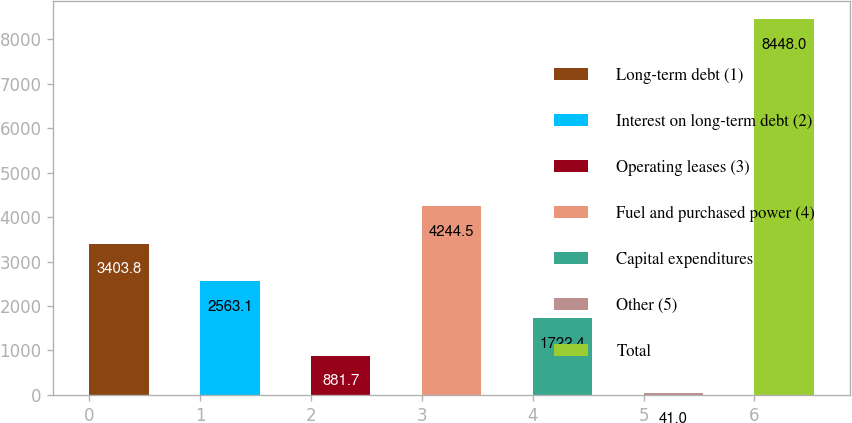<chart> <loc_0><loc_0><loc_500><loc_500><bar_chart><fcel>Long-term debt (1)<fcel>Interest on long-term debt (2)<fcel>Operating leases (3)<fcel>Fuel and purchased power (4)<fcel>Capital expenditures<fcel>Other (5)<fcel>Total<nl><fcel>3403.8<fcel>2563.1<fcel>881.7<fcel>4244.5<fcel>1722.4<fcel>41<fcel>8448<nl></chart> 